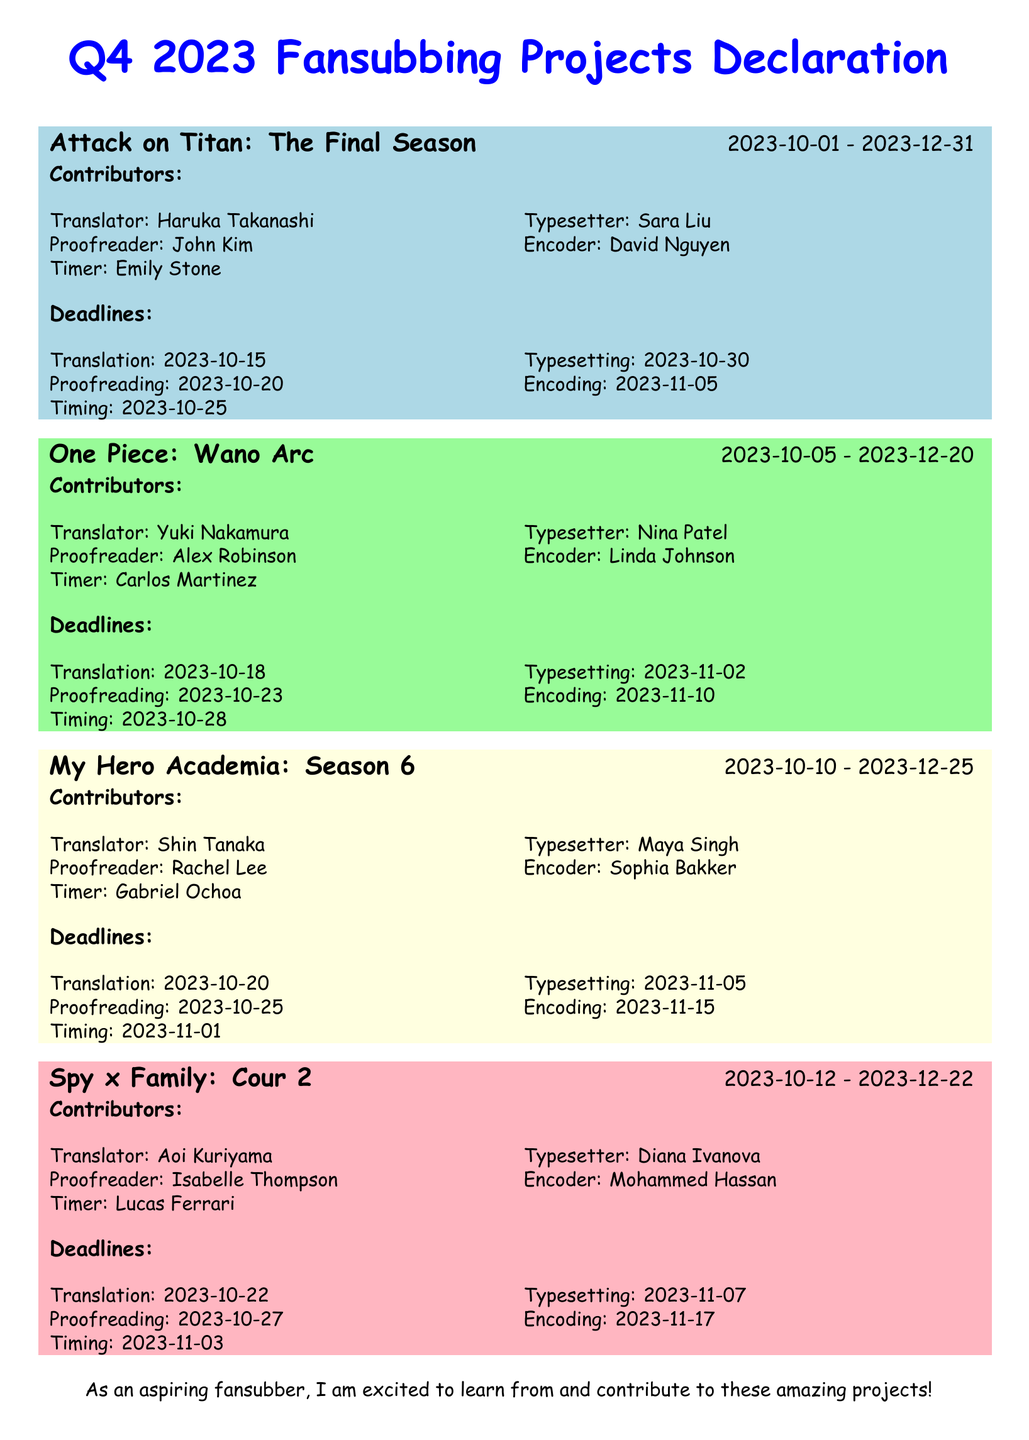What is the title of the first project? The title of the first project is listed at the top of the first project block in the document.
Answer: Attack on Titan: The Final Season Who is the translator for One Piece: Wano Arc? The translator's name is mentioned in the project block for One Piece: Wano Arc.
Answer: Yuki Nakamura What is the deadline for proofreading My Hero Academia: Season 6? The deadline is specified in the deadlines section of the My Hero Academia: Season 6 project block.
Answer: 2023-10-25 How many days do contributors have to complete the timing for Spy x Family: Cour 2? To calculate the days, consider the date mentioned for timing and compare it to the project start date.
Answer: 22 days Which project has a completion date of December 31, 2023? The completion date is indicated at the end of the project details for that specific project.
Answer: Attack on Titan: The Final Season Who is the encoder for My Hero Academia: Season 6? The encoder's name is included in the contributor roles for My Hero Academia: Season 6.
Answer: Sophia Bakker What is the overall timeframe for the projects? The timeframe is given by the earliest start date and latest end date in the document.
Answer: October 1, 2023 - December 31, 2023 What color signifies the One Piece: Wano Arc project? The color used in the project block for One Piece: Wano Arc is specified in the document.
Answer: pastelgreen How many projects are listed in the document? The number of projects is evident from the total project blocks present in the declaration.
Answer: 4 